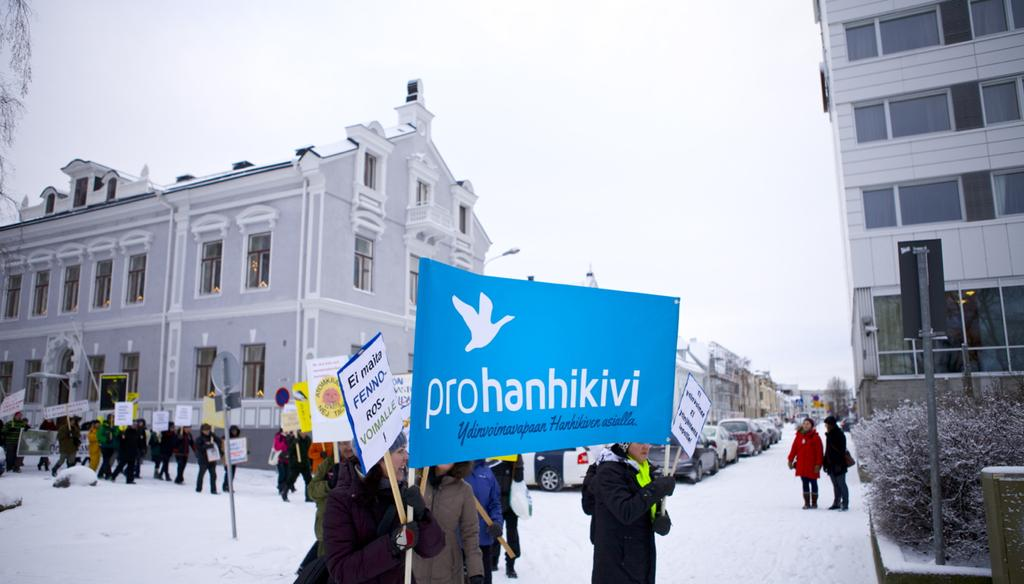<image>
Share a concise interpretation of the image provided. Protesters supporting Prohanhikivi organization out in the snow. 